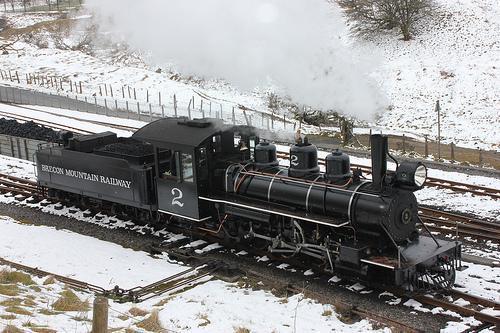How many trains are there?
Give a very brief answer. 1. 